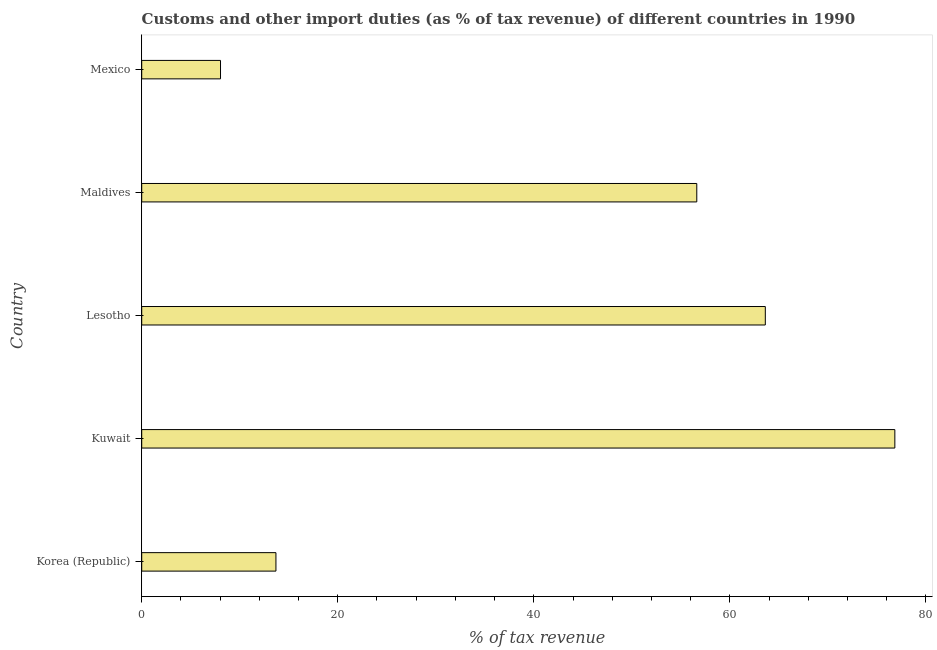Does the graph contain grids?
Your answer should be very brief. No. What is the title of the graph?
Your answer should be compact. Customs and other import duties (as % of tax revenue) of different countries in 1990. What is the label or title of the X-axis?
Your response must be concise. % of tax revenue. What is the label or title of the Y-axis?
Make the answer very short. Country. What is the customs and other import duties in Maldives?
Provide a succinct answer. 56.62. Across all countries, what is the maximum customs and other import duties?
Your answer should be compact. 76.83. Across all countries, what is the minimum customs and other import duties?
Your answer should be compact. 8.04. In which country was the customs and other import duties maximum?
Provide a succinct answer. Kuwait. What is the sum of the customs and other import duties?
Make the answer very short. 218.8. What is the difference between the customs and other import duties in Kuwait and Mexico?
Offer a very short reply. 68.79. What is the average customs and other import duties per country?
Make the answer very short. 43.76. What is the median customs and other import duties?
Provide a succinct answer. 56.62. In how many countries, is the customs and other import duties greater than 44 %?
Your answer should be compact. 3. What is the ratio of the customs and other import duties in Kuwait to that in Mexico?
Your answer should be very brief. 9.56. Is the customs and other import duties in Korea (Republic) less than that in Mexico?
Make the answer very short. No. Is the difference between the customs and other import duties in Kuwait and Maldives greater than the difference between any two countries?
Give a very brief answer. No. What is the difference between the highest and the second highest customs and other import duties?
Give a very brief answer. 13.21. What is the difference between the highest and the lowest customs and other import duties?
Keep it short and to the point. 68.79. How many bars are there?
Make the answer very short. 5. What is the difference between two consecutive major ticks on the X-axis?
Your response must be concise. 20. Are the values on the major ticks of X-axis written in scientific E-notation?
Provide a short and direct response. No. What is the % of tax revenue of Korea (Republic)?
Provide a succinct answer. 13.69. What is the % of tax revenue in Kuwait?
Make the answer very short. 76.83. What is the % of tax revenue of Lesotho?
Give a very brief answer. 63.62. What is the % of tax revenue in Maldives?
Provide a succinct answer. 56.62. What is the % of tax revenue in Mexico?
Ensure brevity in your answer.  8.04. What is the difference between the % of tax revenue in Korea (Republic) and Kuwait?
Give a very brief answer. -63.14. What is the difference between the % of tax revenue in Korea (Republic) and Lesotho?
Ensure brevity in your answer.  -49.92. What is the difference between the % of tax revenue in Korea (Republic) and Maldives?
Offer a very short reply. -42.93. What is the difference between the % of tax revenue in Korea (Republic) and Mexico?
Your answer should be very brief. 5.65. What is the difference between the % of tax revenue in Kuwait and Lesotho?
Offer a terse response. 13.21. What is the difference between the % of tax revenue in Kuwait and Maldives?
Your answer should be compact. 20.2. What is the difference between the % of tax revenue in Kuwait and Mexico?
Offer a very short reply. 68.79. What is the difference between the % of tax revenue in Lesotho and Maldives?
Offer a very short reply. 6.99. What is the difference between the % of tax revenue in Lesotho and Mexico?
Give a very brief answer. 55.58. What is the difference between the % of tax revenue in Maldives and Mexico?
Your response must be concise. 48.59. What is the ratio of the % of tax revenue in Korea (Republic) to that in Kuwait?
Your answer should be very brief. 0.18. What is the ratio of the % of tax revenue in Korea (Republic) to that in Lesotho?
Offer a very short reply. 0.21. What is the ratio of the % of tax revenue in Korea (Republic) to that in Maldives?
Your answer should be very brief. 0.24. What is the ratio of the % of tax revenue in Korea (Republic) to that in Mexico?
Offer a terse response. 1.7. What is the ratio of the % of tax revenue in Kuwait to that in Lesotho?
Give a very brief answer. 1.21. What is the ratio of the % of tax revenue in Kuwait to that in Maldives?
Offer a very short reply. 1.36. What is the ratio of the % of tax revenue in Kuwait to that in Mexico?
Give a very brief answer. 9.56. What is the ratio of the % of tax revenue in Lesotho to that in Maldives?
Your answer should be very brief. 1.12. What is the ratio of the % of tax revenue in Lesotho to that in Mexico?
Your response must be concise. 7.91. What is the ratio of the % of tax revenue in Maldives to that in Mexico?
Keep it short and to the point. 7.04. 